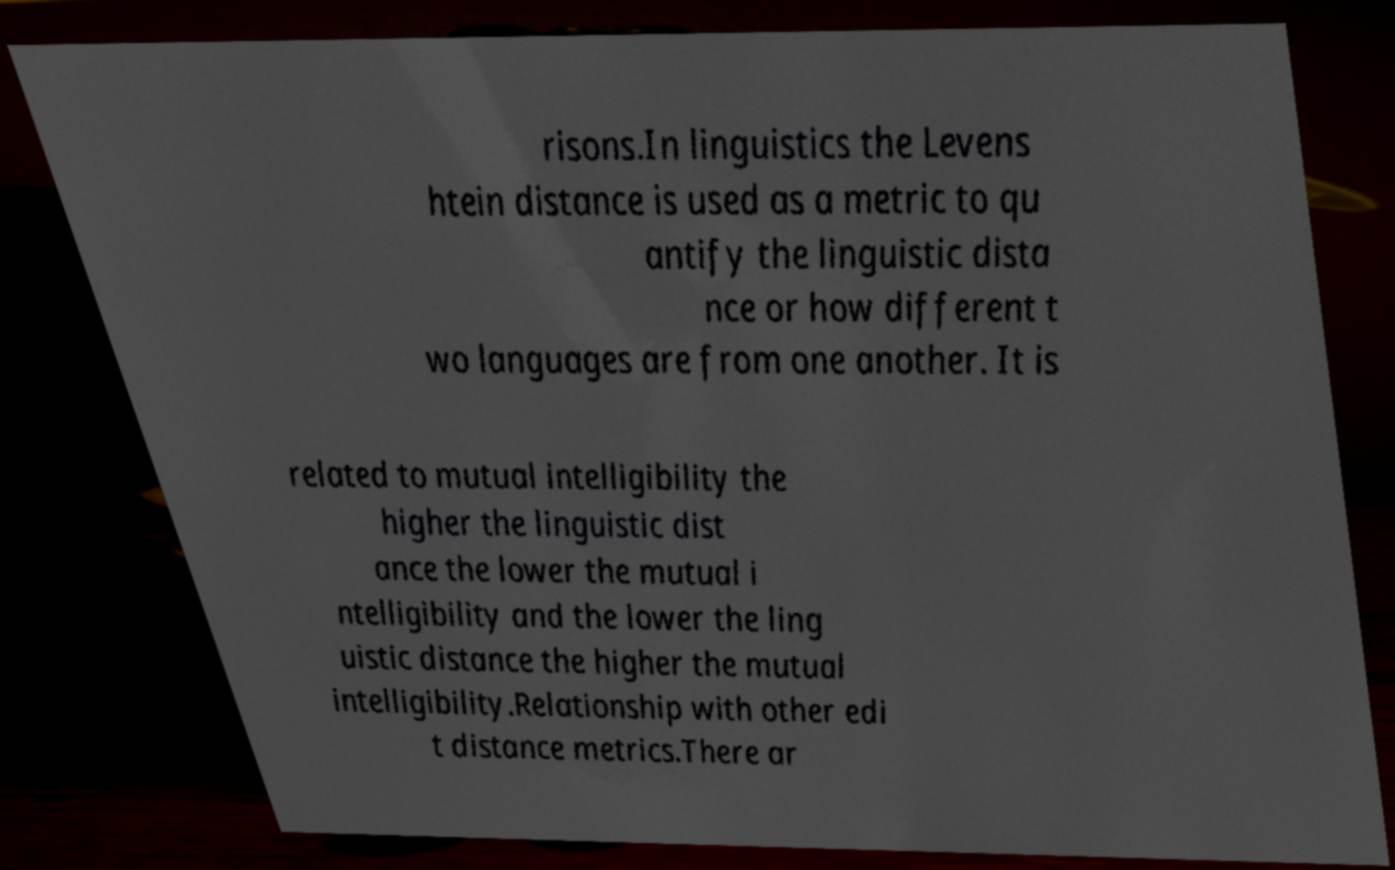Please identify and transcribe the text found in this image. risons.In linguistics the Levens htein distance is used as a metric to qu antify the linguistic dista nce or how different t wo languages are from one another. It is related to mutual intelligibility the higher the linguistic dist ance the lower the mutual i ntelligibility and the lower the ling uistic distance the higher the mutual intelligibility.Relationship with other edi t distance metrics.There ar 